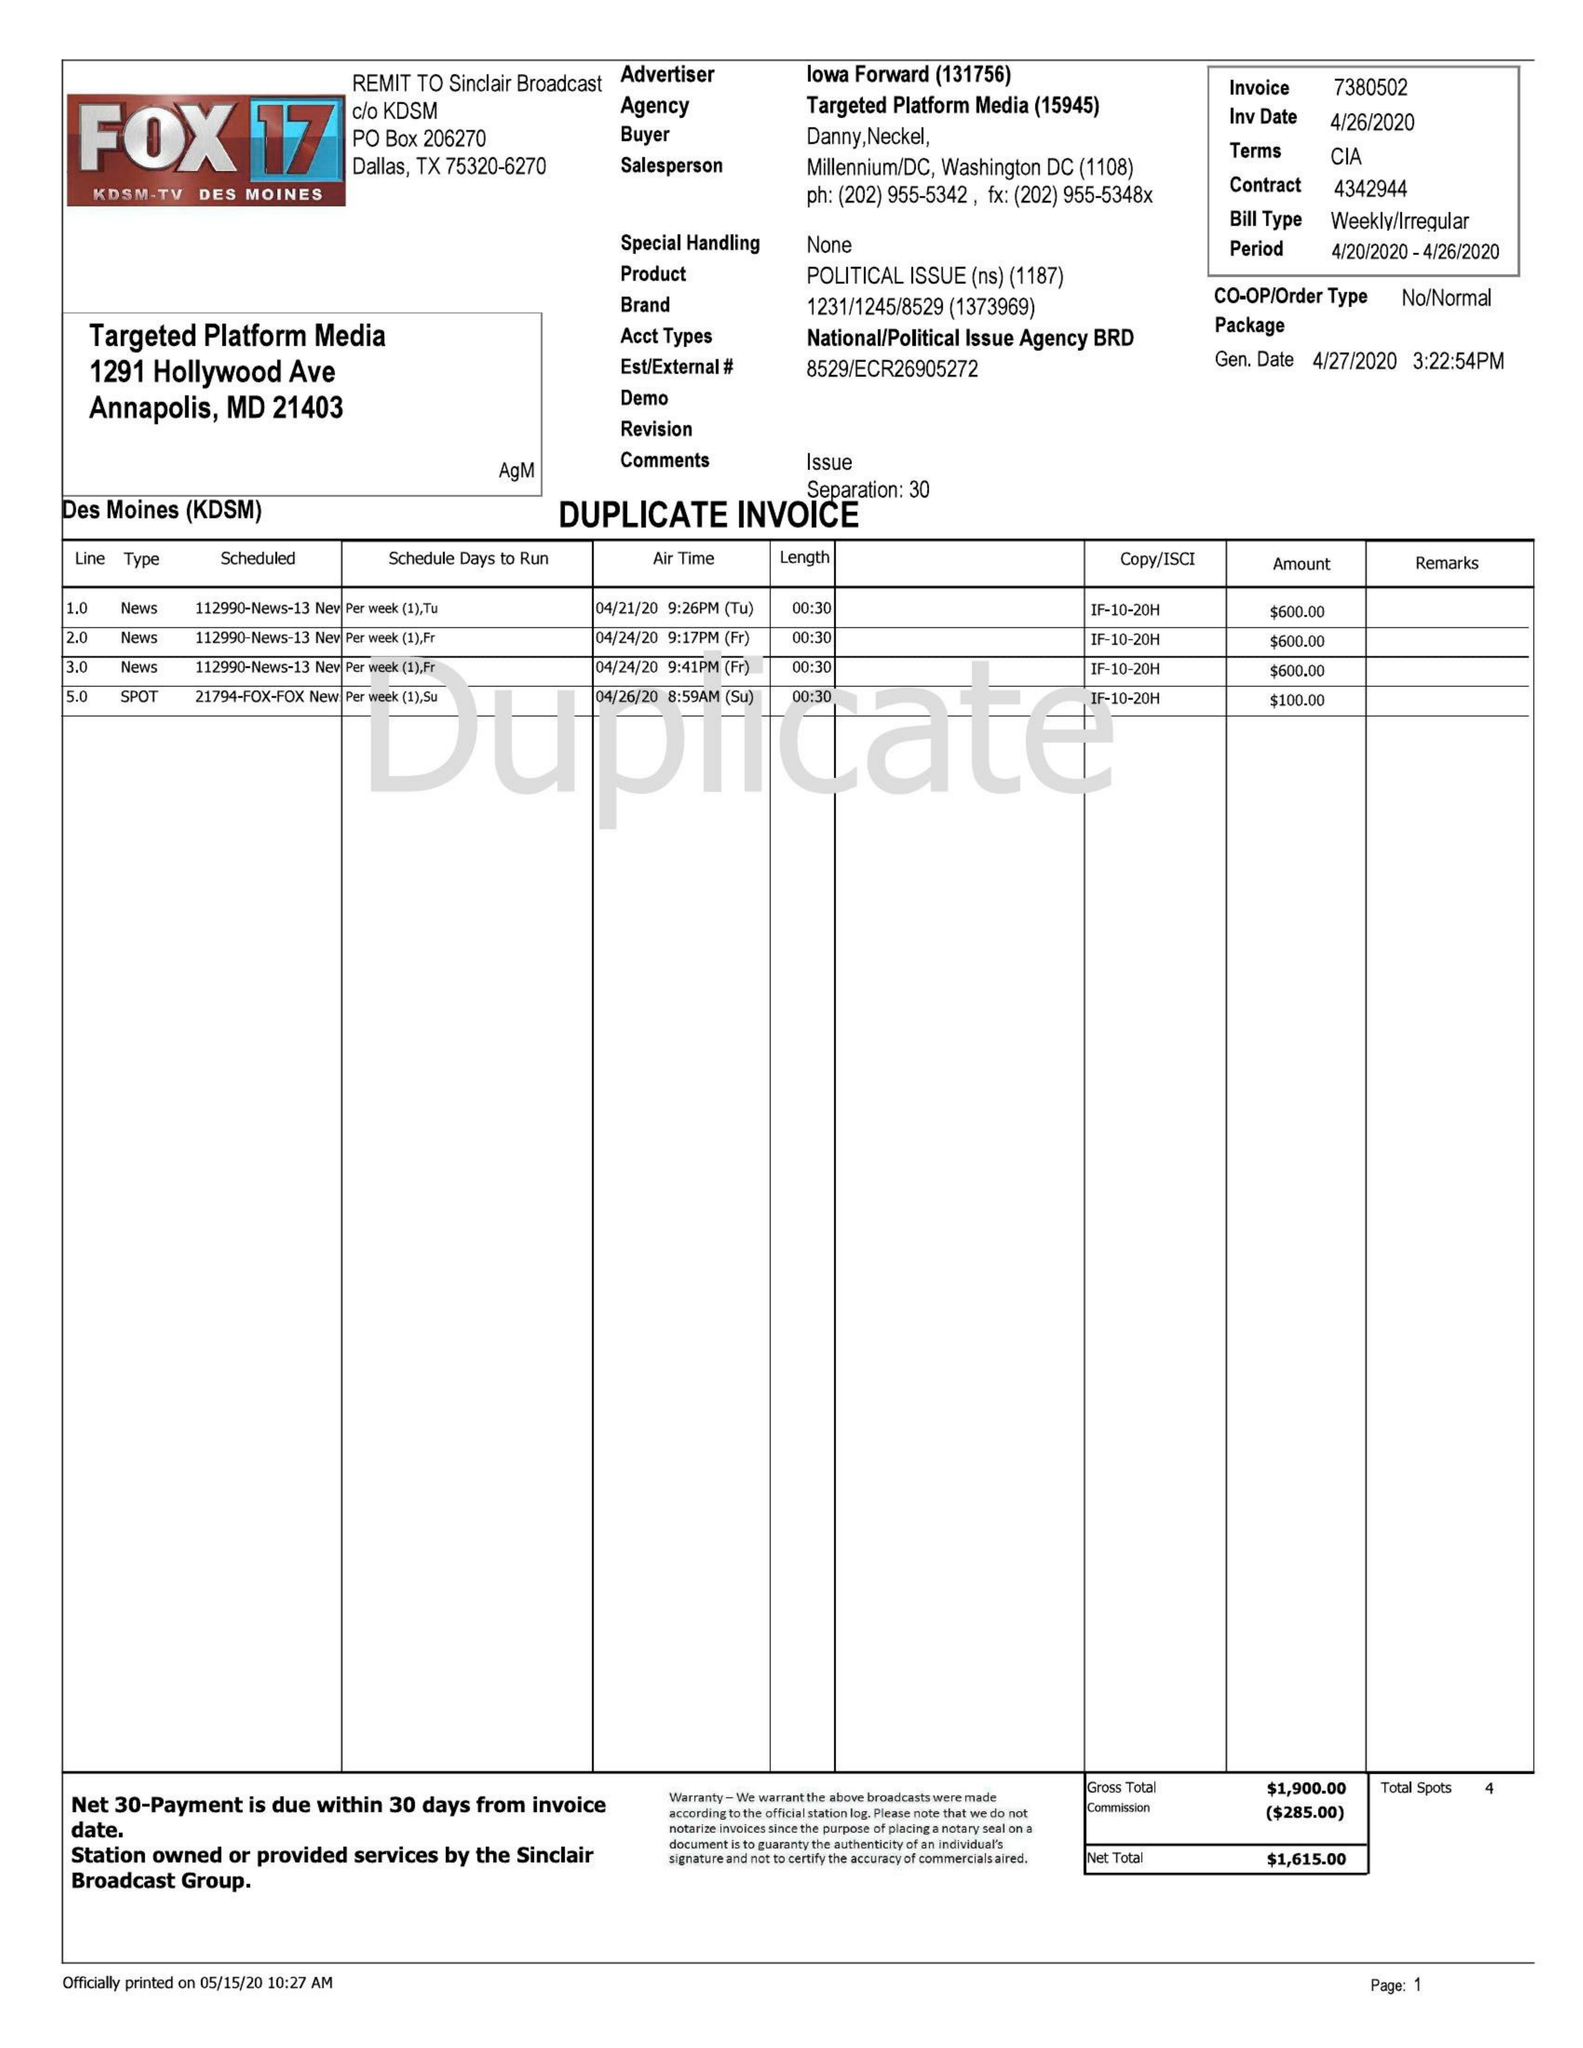What is the value for the contract_num?
Answer the question using a single word or phrase. 7380502 